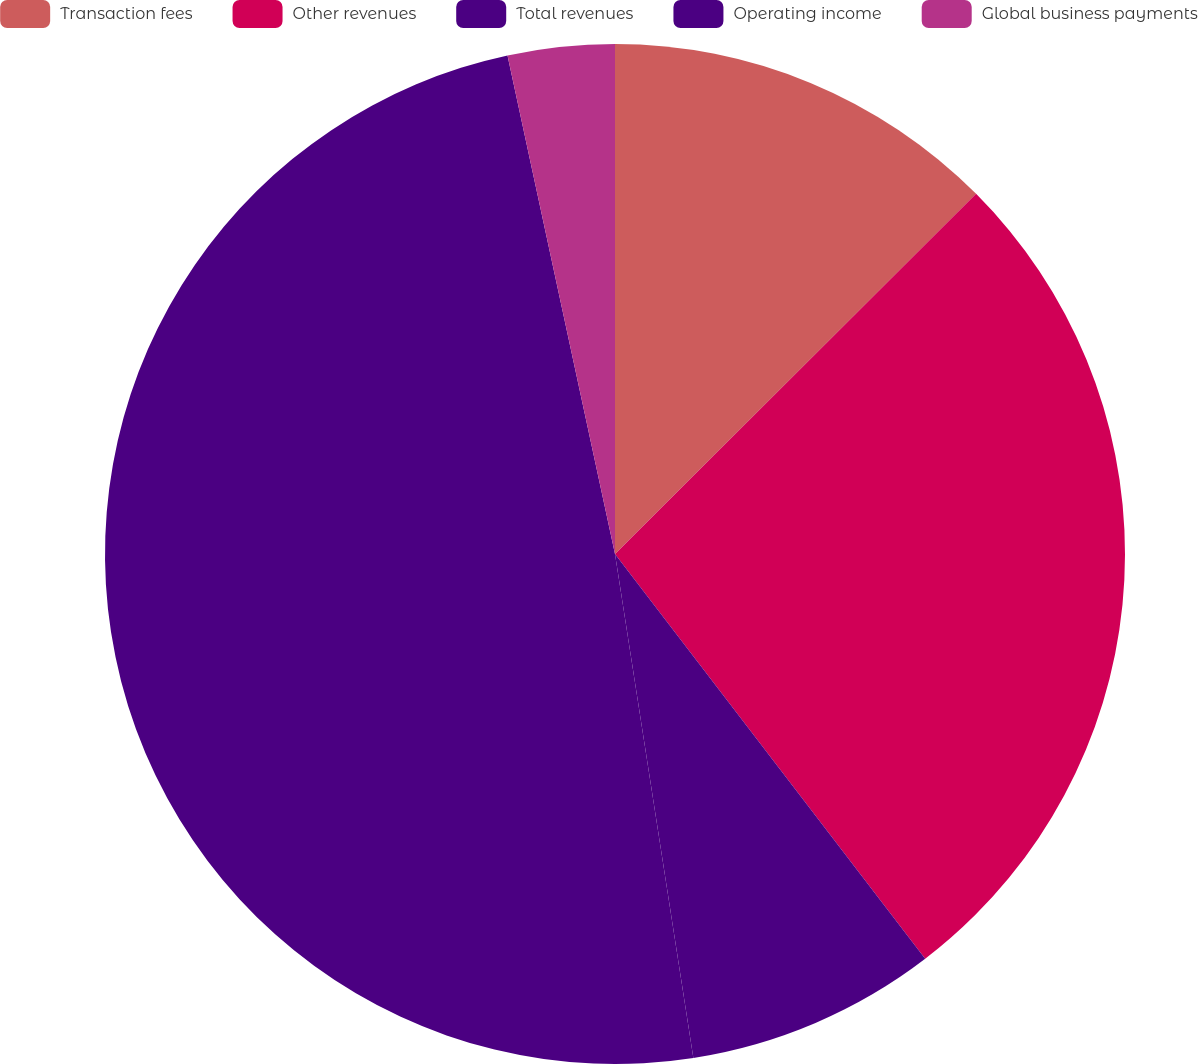<chart> <loc_0><loc_0><loc_500><loc_500><pie_chart><fcel>Transaction fees<fcel>Other revenues<fcel>Total revenues<fcel>Operating income<fcel>Global business payments<nl><fcel>12.52%<fcel>27.07%<fcel>7.95%<fcel>49.07%<fcel>3.38%<nl></chart> 